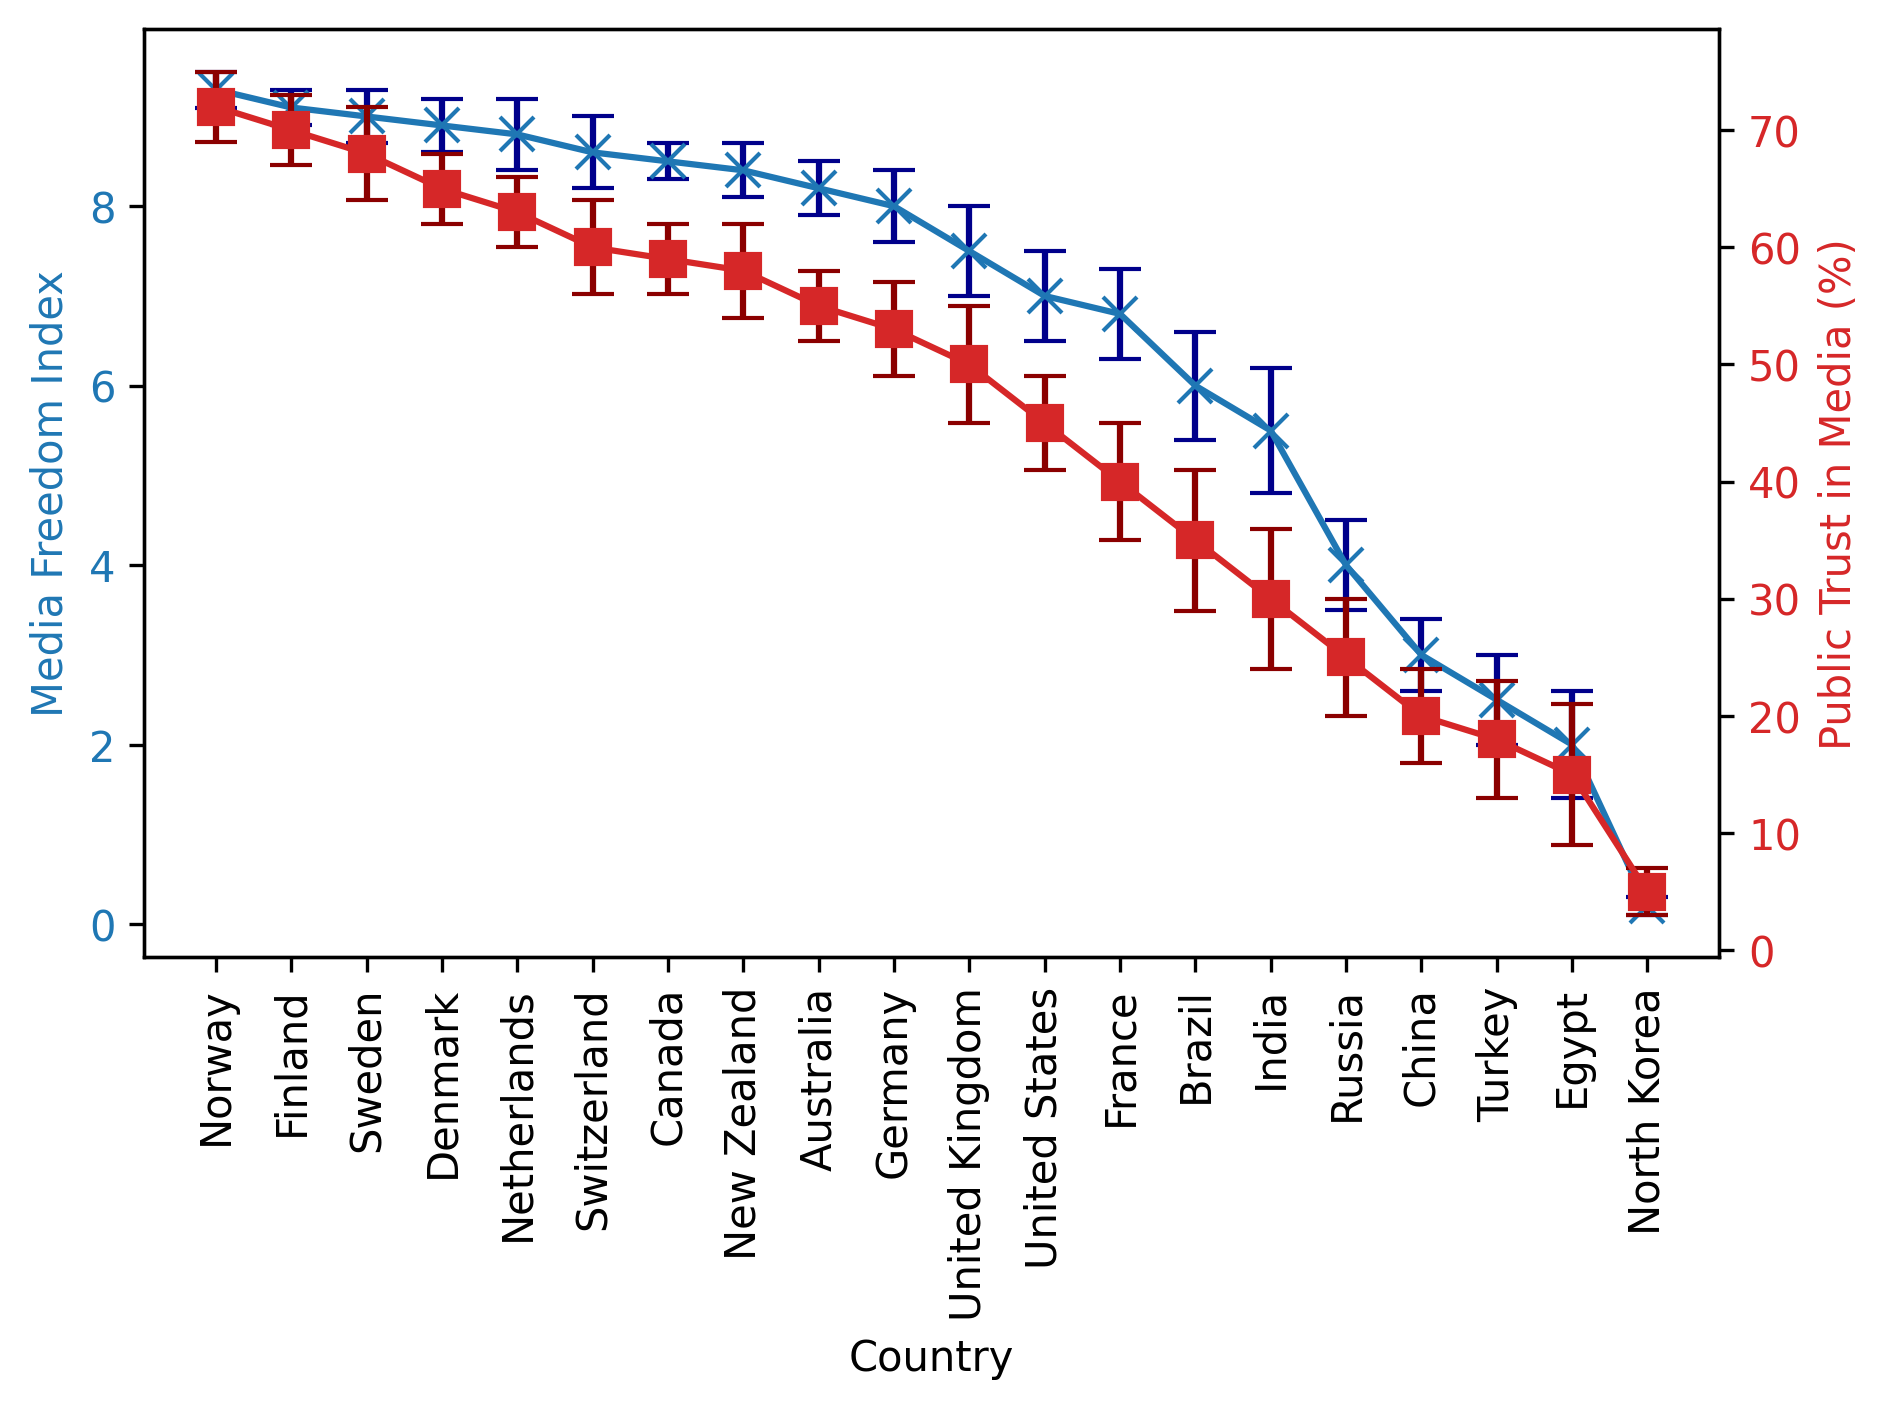Which country has the highest Media Freedom Index? The country with the highest Media Freedom Index is the one with the tallest blue error bar. Upon examining the chart, Norway has the highest value.
Answer: Norway Which country has the lowest Public Trust in Media? The country with the lowest Public Trust in Media is the one with the lowest red error bar. Upon looking at the chart, North Korea has the lowest value.
Answer: North Korea How much higher is the Media Freedom Index in Norway compared to the United States? Locate Norway and the United States on the Media Freedom Index and subtract the United States' index value from Norway's. Norway has a value of 9.3 and the United States has 7.0, the difference is 9.3 - 7.0.
Answer: 2.3 Which country shows greater variability in Public Trust in Media, Brazil or Germany? Compare the length of the error bars for Public Trust in Media between Brazil and Germany. Brazil has a trust standard deviation of 6 and Germany has a standard deviation of 4. Thus, Brazil shows greater variability.
Answer: Brazil What is the median value of the Media Freedom Index for the provided countries? Organize the Media Freedom Index values in ascending order and find the middle value. There are 20 countries, so the median is the average of the 10th and 11th values (8.4 and 8.5). The average is (8.4 + 8.5) / 2.
Answer: 8.45 Which countries have a Media Freedom Index greater than 8.0 and Public Trust in Media greater than 60%? Identify countries where both conditions are satisfied by checking the blue error bars for Media Freedom Index > 8.0 and red error bars for Public Trust in Media > 60%. The countries are Norway, Finland, Sweden, Denmark, Netherlands, and Switzerland.
Answer: Norway, Finland, Sweden, Denmark, Netherlands, Switzerland What is the average Public Trust in Media for countries with a Media Freedom Index less than 6.0? Identify countries with a Media Freedom Index < 6.0 and calculate the average Public Trust in Media. The countries are Brazil, India, Russia, China, Turkey, Egypt, North Korea. Sum their Trust values (35 + 30 + 25 + 20 + 18 + 15 + 5 = 148) and divide by 7.
Answer: 21.14 Which country has the smallest error bar for Media Freedom Index? Find the country with the shortest blue error bar. Based on the chart, both Norway and Finland have the smallest error bars with a standard deviation of 0.2.
Answer: Norway, Finland Is there a visible correlation between Media Freedom Index and Public Trust in Media? By examining the plot, we need to observe if countries with higher Media Freedom Indexes tend to also have higher Public Trust in Media and vice versa. The trend indicates that the higher the Media Freedom Index, the higher the Public Trust in Media.
Answer: Yes How does the Public Trust in Media variability in Turkey compare to the United Kingdom? Compare the length of the red error bars for Turkey and the United Kingdom. Turkey has a standard deviation of 5 and the United Kingdom also has a standard deviation of 5, meaning they have equal variability.
Answer: They have equal variability 